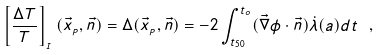<formula> <loc_0><loc_0><loc_500><loc_500>\left [ \frac { \Delta T } { T } \right ] _ { _ { I } } ( \vec { x } _ { _ { P } } , \vec { n } ) = \Delta ( \vec { x } _ { _ { P } } , \vec { n } ) = - 2 \int _ { t _ { 5 0 } } ^ { t _ { o } } ( \vec { \nabla } \phi \cdot \vec { n } ) \dot { \lambda } ( a ) d t \ ,</formula> 